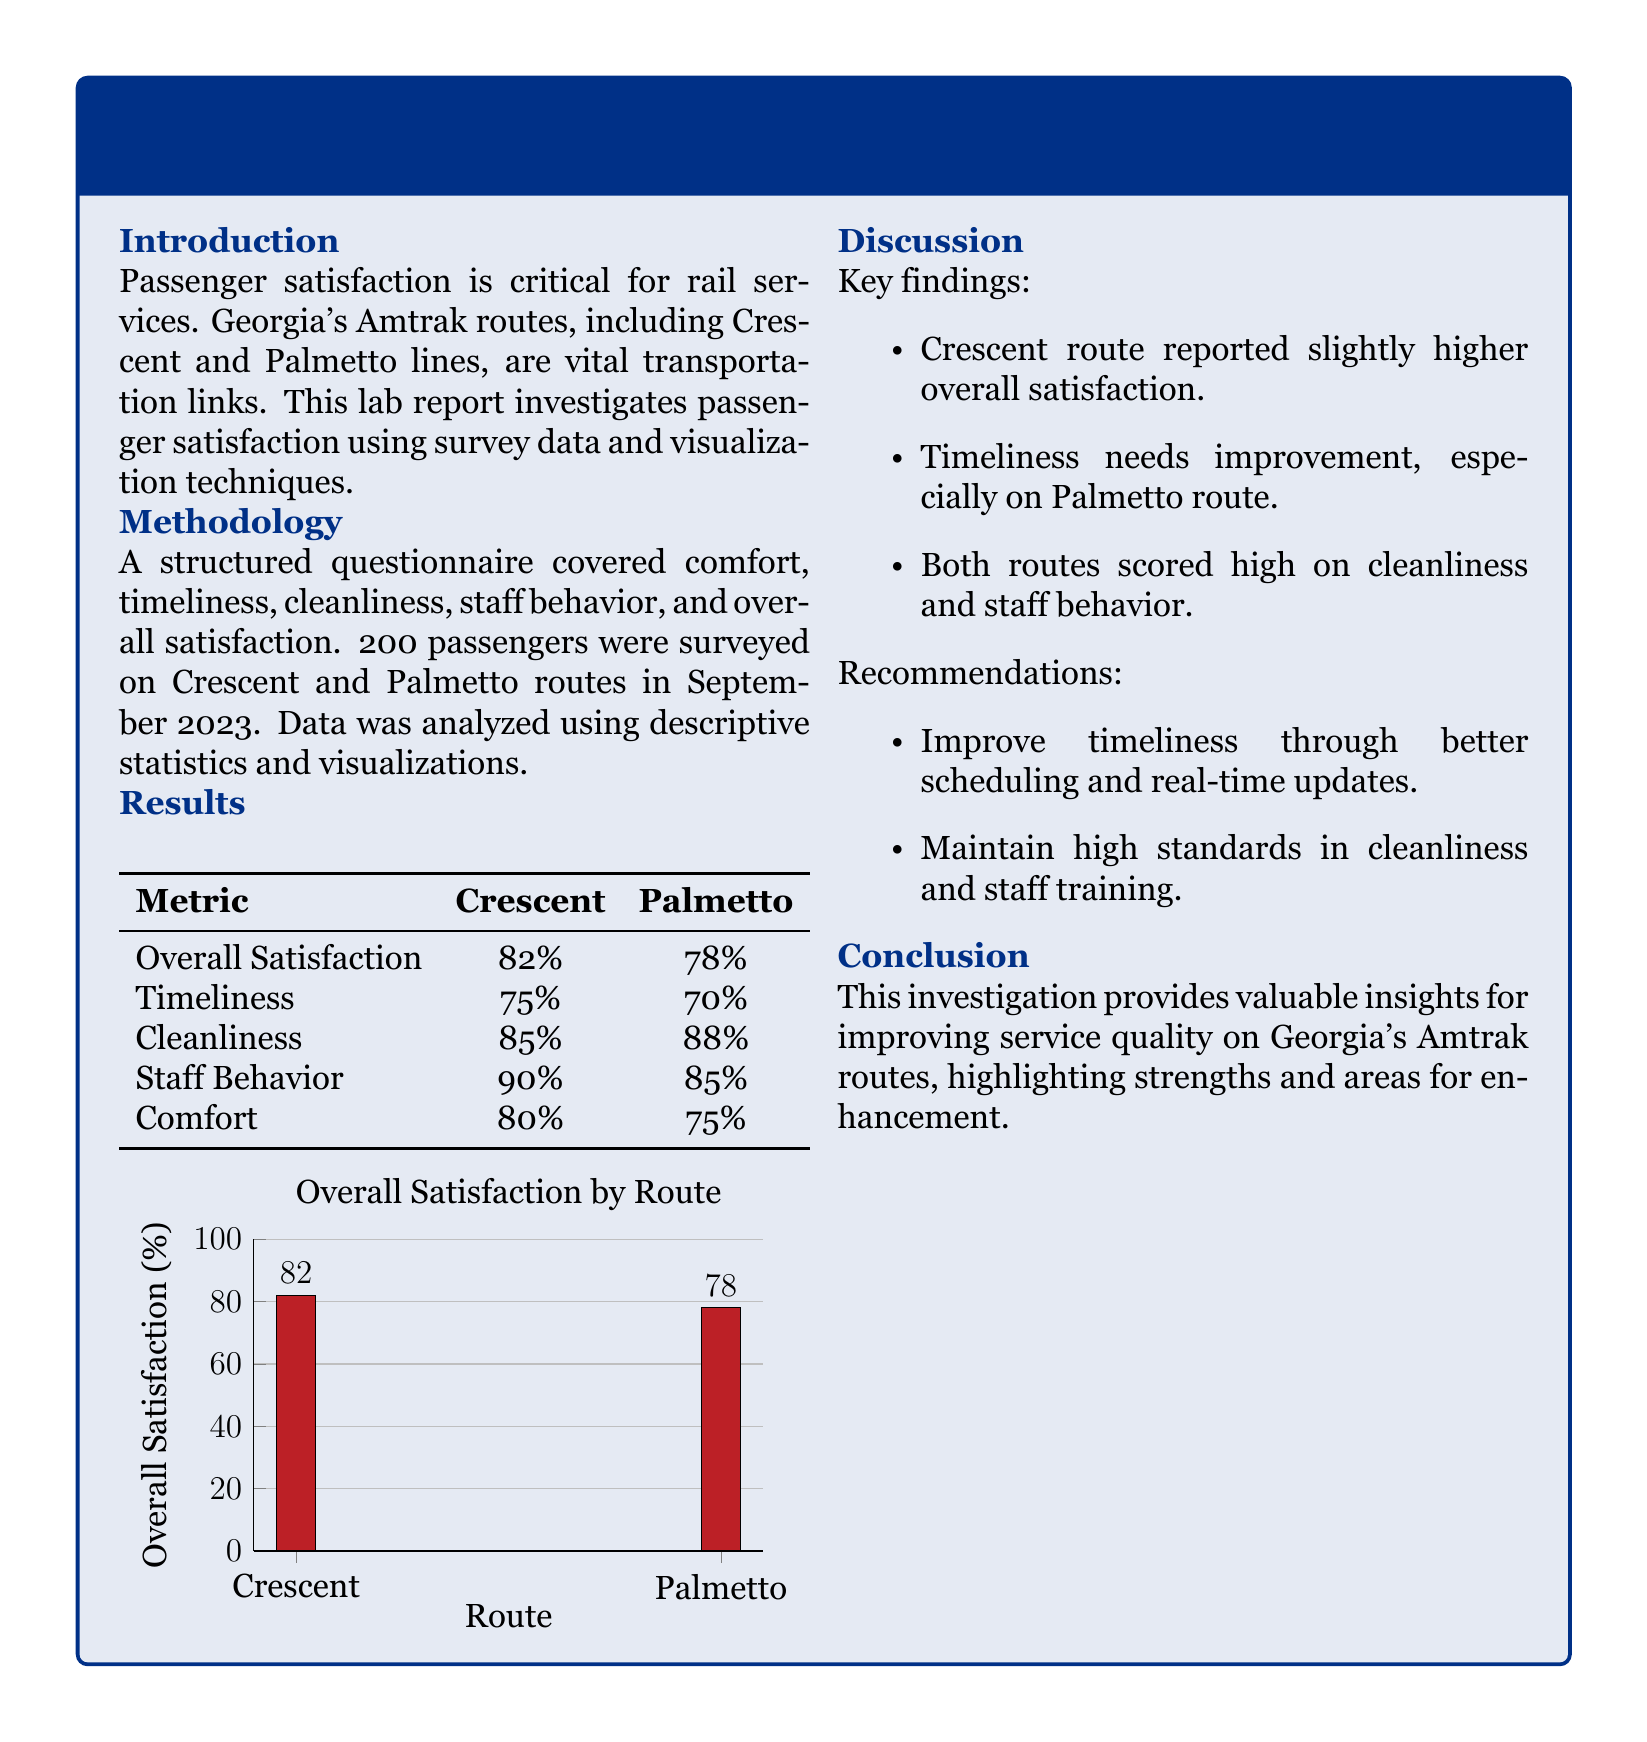What was the overall satisfaction percentage for the Crescent route? The overall satisfaction for the Crescent route is presented in the results section of the report.
Answer: 82% What metric scored the highest for the Palmetto route? The cleanliness metric recorded the highest satisfaction percentage for the Palmetto route according to the results table.
Answer: 88% What percentage of passengers felt that staff behavior was satisfactory on the Crescent route? Staff behavior satisfaction for the Crescent route is detailed in the results section.
Answer: 90% What is the primary focus of this lab report? The main focus of the lab report is detailed in the introduction section, which discusses passenger satisfaction on rail services.
Answer: Passenger satisfaction Which route requires improvements in timeliness according to the discussion? The discussion highlights that one of the routes has a specific need for improvement in timeliness.
Answer: Palmetto route How many passengers were surveyed for this investigation? The methodology section details the number of passengers surveyed for the research study.
Answer: 200 What recommendation is made to improve timeliness? The recommendations in the report provide suggestions for enhancing timeliness, specifically in relation to scheduling.
Answer: Better scheduling What method was used to analyze the survey data? The methodology outlines the type of analysis performed on the collected data from the surveys.
Answer: Descriptive statistics and visualizations 